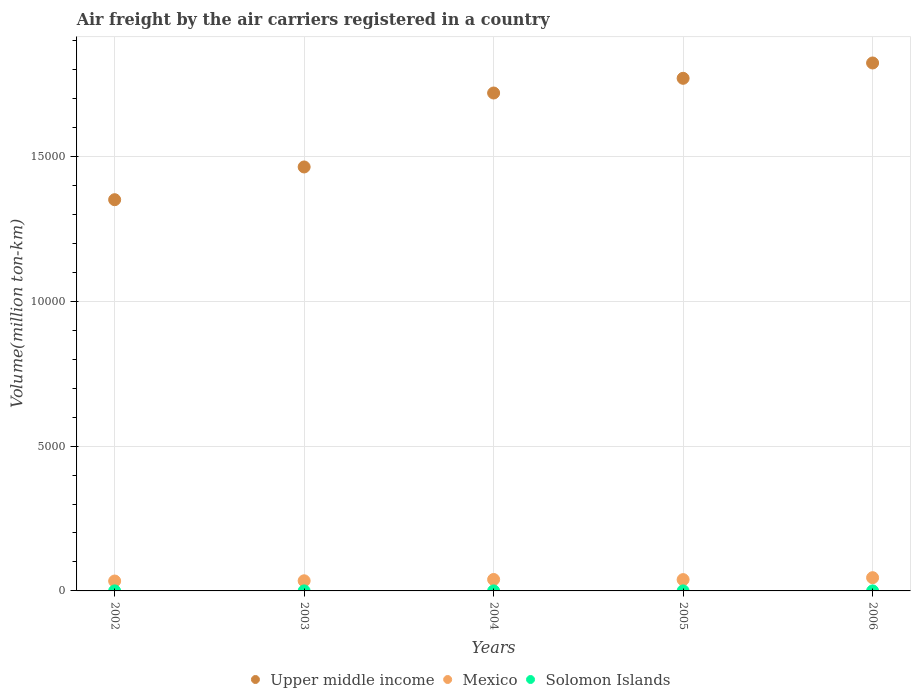How many different coloured dotlines are there?
Offer a very short reply. 3. Is the number of dotlines equal to the number of legend labels?
Keep it short and to the point. Yes. What is the volume of the air carriers in Upper middle income in 2006?
Offer a terse response. 1.82e+04. Across all years, what is the maximum volume of the air carriers in Upper middle income?
Offer a very short reply. 1.82e+04. Across all years, what is the minimum volume of the air carriers in Solomon Islands?
Your answer should be very brief. 0.66. In which year was the volume of the air carriers in Upper middle income minimum?
Offer a terse response. 2002. What is the total volume of the air carriers in Mexico in the graph?
Your answer should be compact. 1934. What is the difference between the volume of the air carriers in Solomon Islands in 2002 and that in 2006?
Make the answer very short. 0.26. What is the difference between the volume of the air carriers in Mexico in 2004 and the volume of the air carriers in Solomon Islands in 2003?
Offer a very short reply. 394.27. What is the average volume of the air carriers in Mexico per year?
Your response must be concise. 386.8. In the year 2003, what is the difference between the volume of the air carriers in Solomon Islands and volume of the air carriers in Upper middle income?
Your response must be concise. -1.46e+04. What is the ratio of the volume of the air carriers in Solomon Islands in 2003 to that in 2005?
Your response must be concise. 0.83. Is the volume of the air carriers in Solomon Islands in 2003 less than that in 2004?
Your answer should be compact. Yes. What is the difference between the highest and the second highest volume of the air carriers in Mexico?
Your answer should be compact. 62.03. What is the difference between the highest and the lowest volume of the air carriers in Upper middle income?
Provide a short and direct response. 4720.92. In how many years, is the volume of the air carriers in Mexico greater than the average volume of the air carriers in Mexico taken over all years?
Offer a very short reply. 3. Is the sum of the volume of the air carriers in Mexico in 2002 and 2004 greater than the maximum volume of the air carriers in Upper middle income across all years?
Make the answer very short. No. Does the volume of the air carriers in Mexico monotonically increase over the years?
Keep it short and to the point. No. How many dotlines are there?
Your answer should be very brief. 3. Does the graph contain grids?
Your response must be concise. Yes. Where does the legend appear in the graph?
Make the answer very short. Bottom center. How are the legend labels stacked?
Keep it short and to the point. Horizontal. What is the title of the graph?
Your response must be concise. Air freight by the air carriers registered in a country. What is the label or title of the X-axis?
Make the answer very short. Years. What is the label or title of the Y-axis?
Give a very brief answer. Volume(million ton-km). What is the Volume(million ton-km) in Upper middle income in 2002?
Your response must be concise. 1.35e+04. What is the Volume(million ton-km) of Mexico in 2002?
Your response must be concise. 341.6. What is the Volume(million ton-km) of Solomon Islands in 2002?
Ensure brevity in your answer.  1.09. What is the Volume(million ton-km) in Upper middle income in 2003?
Keep it short and to the point. 1.46e+04. What is the Volume(million ton-km) of Mexico in 2003?
Give a very brief answer. 350.09. What is the Volume(million ton-km) in Solomon Islands in 2003?
Ensure brevity in your answer.  0.66. What is the Volume(million ton-km) in Upper middle income in 2004?
Keep it short and to the point. 1.72e+04. What is the Volume(million ton-km) in Mexico in 2004?
Provide a succinct answer. 394.93. What is the Volume(million ton-km) of Solomon Islands in 2004?
Give a very brief answer. 0.77. What is the Volume(million ton-km) of Upper middle income in 2005?
Ensure brevity in your answer.  1.77e+04. What is the Volume(million ton-km) in Mexico in 2005?
Give a very brief answer. 390.43. What is the Volume(million ton-km) of Solomon Islands in 2005?
Offer a terse response. 0.8. What is the Volume(million ton-km) of Upper middle income in 2006?
Offer a terse response. 1.82e+04. What is the Volume(million ton-km) in Mexico in 2006?
Provide a succinct answer. 456.96. What is the Volume(million ton-km) in Solomon Islands in 2006?
Your response must be concise. 0.83. Across all years, what is the maximum Volume(million ton-km) in Upper middle income?
Ensure brevity in your answer.  1.82e+04. Across all years, what is the maximum Volume(million ton-km) of Mexico?
Ensure brevity in your answer.  456.96. Across all years, what is the maximum Volume(million ton-km) in Solomon Islands?
Give a very brief answer. 1.09. Across all years, what is the minimum Volume(million ton-km) of Upper middle income?
Offer a terse response. 1.35e+04. Across all years, what is the minimum Volume(million ton-km) of Mexico?
Ensure brevity in your answer.  341.6. Across all years, what is the minimum Volume(million ton-km) in Solomon Islands?
Ensure brevity in your answer.  0.66. What is the total Volume(million ton-km) of Upper middle income in the graph?
Your answer should be very brief. 8.13e+04. What is the total Volume(million ton-km) in Mexico in the graph?
Make the answer very short. 1933.99. What is the total Volume(million ton-km) in Solomon Islands in the graph?
Your answer should be compact. 4.14. What is the difference between the Volume(million ton-km) in Upper middle income in 2002 and that in 2003?
Give a very brief answer. -1130.46. What is the difference between the Volume(million ton-km) of Mexico in 2002 and that in 2003?
Give a very brief answer. -8.49. What is the difference between the Volume(million ton-km) in Solomon Islands in 2002 and that in 2003?
Offer a very short reply. 0.43. What is the difference between the Volume(million ton-km) of Upper middle income in 2002 and that in 2004?
Keep it short and to the point. -3683.9. What is the difference between the Volume(million ton-km) of Mexico in 2002 and that in 2004?
Make the answer very short. -53.33. What is the difference between the Volume(million ton-km) in Solomon Islands in 2002 and that in 2004?
Ensure brevity in your answer.  0.32. What is the difference between the Volume(million ton-km) in Upper middle income in 2002 and that in 2005?
Give a very brief answer. -4191.42. What is the difference between the Volume(million ton-km) of Mexico in 2002 and that in 2005?
Your answer should be compact. -48.83. What is the difference between the Volume(million ton-km) of Solomon Islands in 2002 and that in 2005?
Provide a succinct answer. 0.29. What is the difference between the Volume(million ton-km) in Upper middle income in 2002 and that in 2006?
Ensure brevity in your answer.  -4720.92. What is the difference between the Volume(million ton-km) in Mexico in 2002 and that in 2006?
Offer a very short reply. -115.36. What is the difference between the Volume(million ton-km) in Solomon Islands in 2002 and that in 2006?
Make the answer very short. 0.26. What is the difference between the Volume(million ton-km) in Upper middle income in 2003 and that in 2004?
Provide a succinct answer. -2553.44. What is the difference between the Volume(million ton-km) in Mexico in 2003 and that in 2004?
Your answer should be very brief. -44.84. What is the difference between the Volume(million ton-km) of Solomon Islands in 2003 and that in 2004?
Offer a very short reply. -0.11. What is the difference between the Volume(million ton-km) of Upper middle income in 2003 and that in 2005?
Give a very brief answer. -3060.96. What is the difference between the Volume(million ton-km) of Mexico in 2003 and that in 2005?
Keep it short and to the point. -40.34. What is the difference between the Volume(million ton-km) in Solomon Islands in 2003 and that in 2005?
Offer a terse response. -0.14. What is the difference between the Volume(million ton-km) in Upper middle income in 2003 and that in 2006?
Provide a succinct answer. -3590.45. What is the difference between the Volume(million ton-km) of Mexico in 2003 and that in 2006?
Provide a succinct answer. -106.87. What is the difference between the Volume(million ton-km) of Solomon Islands in 2003 and that in 2006?
Make the answer very short. -0.17. What is the difference between the Volume(million ton-km) in Upper middle income in 2004 and that in 2005?
Your answer should be compact. -507.53. What is the difference between the Volume(million ton-km) in Solomon Islands in 2004 and that in 2005?
Your answer should be very brief. -0.03. What is the difference between the Volume(million ton-km) of Upper middle income in 2004 and that in 2006?
Your response must be concise. -1037.02. What is the difference between the Volume(million ton-km) in Mexico in 2004 and that in 2006?
Give a very brief answer. -62.03. What is the difference between the Volume(million ton-km) in Solomon Islands in 2004 and that in 2006?
Offer a very short reply. -0.06. What is the difference between the Volume(million ton-km) in Upper middle income in 2005 and that in 2006?
Your response must be concise. -529.49. What is the difference between the Volume(million ton-km) of Mexico in 2005 and that in 2006?
Give a very brief answer. -66.53. What is the difference between the Volume(million ton-km) of Solomon Islands in 2005 and that in 2006?
Give a very brief answer. -0.03. What is the difference between the Volume(million ton-km) in Upper middle income in 2002 and the Volume(million ton-km) in Mexico in 2003?
Keep it short and to the point. 1.32e+04. What is the difference between the Volume(million ton-km) in Upper middle income in 2002 and the Volume(million ton-km) in Solomon Islands in 2003?
Provide a short and direct response. 1.35e+04. What is the difference between the Volume(million ton-km) of Mexico in 2002 and the Volume(million ton-km) of Solomon Islands in 2003?
Offer a very short reply. 340.94. What is the difference between the Volume(million ton-km) in Upper middle income in 2002 and the Volume(million ton-km) in Mexico in 2004?
Your answer should be compact. 1.31e+04. What is the difference between the Volume(million ton-km) of Upper middle income in 2002 and the Volume(million ton-km) of Solomon Islands in 2004?
Your response must be concise. 1.35e+04. What is the difference between the Volume(million ton-km) of Mexico in 2002 and the Volume(million ton-km) of Solomon Islands in 2004?
Your answer should be compact. 340.83. What is the difference between the Volume(million ton-km) of Upper middle income in 2002 and the Volume(million ton-km) of Mexico in 2005?
Offer a terse response. 1.31e+04. What is the difference between the Volume(million ton-km) in Upper middle income in 2002 and the Volume(million ton-km) in Solomon Islands in 2005?
Offer a terse response. 1.35e+04. What is the difference between the Volume(million ton-km) in Mexico in 2002 and the Volume(million ton-km) in Solomon Islands in 2005?
Keep it short and to the point. 340.8. What is the difference between the Volume(million ton-km) in Upper middle income in 2002 and the Volume(million ton-km) in Mexico in 2006?
Your answer should be compact. 1.31e+04. What is the difference between the Volume(million ton-km) in Upper middle income in 2002 and the Volume(million ton-km) in Solomon Islands in 2006?
Ensure brevity in your answer.  1.35e+04. What is the difference between the Volume(million ton-km) in Mexico in 2002 and the Volume(million ton-km) in Solomon Islands in 2006?
Make the answer very short. 340.77. What is the difference between the Volume(million ton-km) in Upper middle income in 2003 and the Volume(million ton-km) in Mexico in 2004?
Give a very brief answer. 1.42e+04. What is the difference between the Volume(million ton-km) in Upper middle income in 2003 and the Volume(million ton-km) in Solomon Islands in 2004?
Keep it short and to the point. 1.46e+04. What is the difference between the Volume(million ton-km) in Mexico in 2003 and the Volume(million ton-km) in Solomon Islands in 2004?
Provide a short and direct response. 349.32. What is the difference between the Volume(million ton-km) in Upper middle income in 2003 and the Volume(million ton-km) in Mexico in 2005?
Make the answer very short. 1.42e+04. What is the difference between the Volume(million ton-km) of Upper middle income in 2003 and the Volume(million ton-km) of Solomon Islands in 2005?
Your response must be concise. 1.46e+04. What is the difference between the Volume(million ton-km) in Mexico in 2003 and the Volume(million ton-km) in Solomon Islands in 2005?
Give a very brief answer. 349.29. What is the difference between the Volume(million ton-km) in Upper middle income in 2003 and the Volume(million ton-km) in Mexico in 2006?
Your answer should be compact. 1.42e+04. What is the difference between the Volume(million ton-km) in Upper middle income in 2003 and the Volume(million ton-km) in Solomon Islands in 2006?
Your answer should be very brief. 1.46e+04. What is the difference between the Volume(million ton-km) of Mexico in 2003 and the Volume(million ton-km) of Solomon Islands in 2006?
Your answer should be very brief. 349.26. What is the difference between the Volume(million ton-km) of Upper middle income in 2004 and the Volume(million ton-km) of Mexico in 2005?
Offer a terse response. 1.68e+04. What is the difference between the Volume(million ton-km) of Upper middle income in 2004 and the Volume(million ton-km) of Solomon Islands in 2005?
Offer a terse response. 1.72e+04. What is the difference between the Volume(million ton-km) in Mexico in 2004 and the Volume(million ton-km) in Solomon Islands in 2005?
Your response must be concise. 394.13. What is the difference between the Volume(million ton-km) of Upper middle income in 2004 and the Volume(million ton-km) of Mexico in 2006?
Your answer should be compact. 1.67e+04. What is the difference between the Volume(million ton-km) in Upper middle income in 2004 and the Volume(million ton-km) in Solomon Islands in 2006?
Your answer should be very brief. 1.72e+04. What is the difference between the Volume(million ton-km) of Mexico in 2004 and the Volume(million ton-km) of Solomon Islands in 2006?
Your response must be concise. 394.1. What is the difference between the Volume(million ton-km) of Upper middle income in 2005 and the Volume(million ton-km) of Mexico in 2006?
Provide a short and direct response. 1.72e+04. What is the difference between the Volume(million ton-km) in Upper middle income in 2005 and the Volume(million ton-km) in Solomon Islands in 2006?
Your response must be concise. 1.77e+04. What is the difference between the Volume(million ton-km) of Mexico in 2005 and the Volume(million ton-km) of Solomon Islands in 2006?
Offer a very short reply. 389.6. What is the average Volume(million ton-km) of Upper middle income per year?
Ensure brevity in your answer.  1.63e+04. What is the average Volume(million ton-km) of Mexico per year?
Provide a succinct answer. 386.8. What is the average Volume(million ton-km) in Solomon Islands per year?
Offer a terse response. 0.83. In the year 2002, what is the difference between the Volume(million ton-km) in Upper middle income and Volume(million ton-km) in Mexico?
Offer a very short reply. 1.32e+04. In the year 2002, what is the difference between the Volume(million ton-km) in Upper middle income and Volume(million ton-km) in Solomon Islands?
Your response must be concise. 1.35e+04. In the year 2002, what is the difference between the Volume(million ton-km) in Mexico and Volume(million ton-km) in Solomon Islands?
Provide a succinct answer. 340.51. In the year 2003, what is the difference between the Volume(million ton-km) of Upper middle income and Volume(million ton-km) of Mexico?
Ensure brevity in your answer.  1.43e+04. In the year 2003, what is the difference between the Volume(million ton-km) of Upper middle income and Volume(million ton-km) of Solomon Islands?
Your answer should be compact. 1.46e+04. In the year 2003, what is the difference between the Volume(million ton-km) of Mexico and Volume(million ton-km) of Solomon Islands?
Offer a terse response. 349.43. In the year 2004, what is the difference between the Volume(million ton-km) in Upper middle income and Volume(million ton-km) in Mexico?
Provide a short and direct response. 1.68e+04. In the year 2004, what is the difference between the Volume(million ton-km) in Upper middle income and Volume(million ton-km) in Solomon Islands?
Provide a succinct answer. 1.72e+04. In the year 2004, what is the difference between the Volume(million ton-km) in Mexico and Volume(million ton-km) in Solomon Islands?
Keep it short and to the point. 394.15. In the year 2005, what is the difference between the Volume(million ton-km) of Upper middle income and Volume(million ton-km) of Mexico?
Your response must be concise. 1.73e+04. In the year 2005, what is the difference between the Volume(million ton-km) in Upper middle income and Volume(million ton-km) in Solomon Islands?
Offer a terse response. 1.77e+04. In the year 2005, what is the difference between the Volume(million ton-km) of Mexico and Volume(million ton-km) of Solomon Islands?
Keep it short and to the point. 389.63. In the year 2006, what is the difference between the Volume(million ton-km) of Upper middle income and Volume(million ton-km) of Mexico?
Offer a terse response. 1.78e+04. In the year 2006, what is the difference between the Volume(million ton-km) of Upper middle income and Volume(million ton-km) of Solomon Islands?
Offer a very short reply. 1.82e+04. In the year 2006, what is the difference between the Volume(million ton-km) of Mexico and Volume(million ton-km) of Solomon Islands?
Give a very brief answer. 456.13. What is the ratio of the Volume(million ton-km) in Upper middle income in 2002 to that in 2003?
Give a very brief answer. 0.92. What is the ratio of the Volume(million ton-km) of Mexico in 2002 to that in 2003?
Offer a terse response. 0.98. What is the ratio of the Volume(million ton-km) of Solomon Islands in 2002 to that in 2003?
Your answer should be compact. 1.65. What is the ratio of the Volume(million ton-km) in Upper middle income in 2002 to that in 2004?
Offer a terse response. 0.79. What is the ratio of the Volume(million ton-km) of Mexico in 2002 to that in 2004?
Give a very brief answer. 0.86. What is the ratio of the Volume(million ton-km) of Solomon Islands in 2002 to that in 2004?
Your response must be concise. 1.41. What is the ratio of the Volume(million ton-km) of Upper middle income in 2002 to that in 2005?
Your response must be concise. 0.76. What is the ratio of the Volume(million ton-km) of Mexico in 2002 to that in 2005?
Your answer should be compact. 0.87. What is the ratio of the Volume(million ton-km) in Solomon Islands in 2002 to that in 2005?
Provide a short and direct response. 1.36. What is the ratio of the Volume(million ton-km) of Upper middle income in 2002 to that in 2006?
Make the answer very short. 0.74. What is the ratio of the Volume(million ton-km) in Mexico in 2002 to that in 2006?
Ensure brevity in your answer.  0.75. What is the ratio of the Volume(million ton-km) in Solomon Islands in 2002 to that in 2006?
Offer a very short reply. 1.31. What is the ratio of the Volume(million ton-km) in Upper middle income in 2003 to that in 2004?
Offer a terse response. 0.85. What is the ratio of the Volume(million ton-km) of Mexico in 2003 to that in 2004?
Give a very brief answer. 0.89. What is the ratio of the Volume(million ton-km) in Solomon Islands in 2003 to that in 2004?
Give a very brief answer. 0.85. What is the ratio of the Volume(million ton-km) of Upper middle income in 2003 to that in 2005?
Provide a succinct answer. 0.83. What is the ratio of the Volume(million ton-km) in Mexico in 2003 to that in 2005?
Offer a terse response. 0.9. What is the ratio of the Volume(million ton-km) in Solomon Islands in 2003 to that in 2005?
Offer a very short reply. 0.83. What is the ratio of the Volume(million ton-km) in Upper middle income in 2003 to that in 2006?
Provide a succinct answer. 0.8. What is the ratio of the Volume(million ton-km) of Mexico in 2003 to that in 2006?
Make the answer very short. 0.77. What is the ratio of the Volume(million ton-km) in Solomon Islands in 2003 to that in 2006?
Keep it short and to the point. 0.8. What is the ratio of the Volume(million ton-km) in Upper middle income in 2004 to that in 2005?
Offer a terse response. 0.97. What is the ratio of the Volume(million ton-km) in Mexico in 2004 to that in 2005?
Your answer should be compact. 1.01. What is the ratio of the Volume(million ton-km) of Solomon Islands in 2004 to that in 2005?
Provide a short and direct response. 0.97. What is the ratio of the Volume(million ton-km) in Upper middle income in 2004 to that in 2006?
Your answer should be very brief. 0.94. What is the ratio of the Volume(million ton-km) in Mexico in 2004 to that in 2006?
Your answer should be very brief. 0.86. What is the ratio of the Volume(million ton-km) of Solomon Islands in 2004 to that in 2006?
Provide a short and direct response. 0.93. What is the ratio of the Volume(million ton-km) in Upper middle income in 2005 to that in 2006?
Your answer should be very brief. 0.97. What is the ratio of the Volume(million ton-km) in Mexico in 2005 to that in 2006?
Offer a very short reply. 0.85. What is the ratio of the Volume(million ton-km) of Solomon Islands in 2005 to that in 2006?
Ensure brevity in your answer.  0.96. What is the difference between the highest and the second highest Volume(million ton-km) of Upper middle income?
Keep it short and to the point. 529.49. What is the difference between the highest and the second highest Volume(million ton-km) in Mexico?
Offer a very short reply. 62.03. What is the difference between the highest and the second highest Volume(million ton-km) in Solomon Islands?
Keep it short and to the point. 0.26. What is the difference between the highest and the lowest Volume(million ton-km) in Upper middle income?
Keep it short and to the point. 4720.92. What is the difference between the highest and the lowest Volume(million ton-km) in Mexico?
Offer a very short reply. 115.36. What is the difference between the highest and the lowest Volume(million ton-km) in Solomon Islands?
Ensure brevity in your answer.  0.43. 